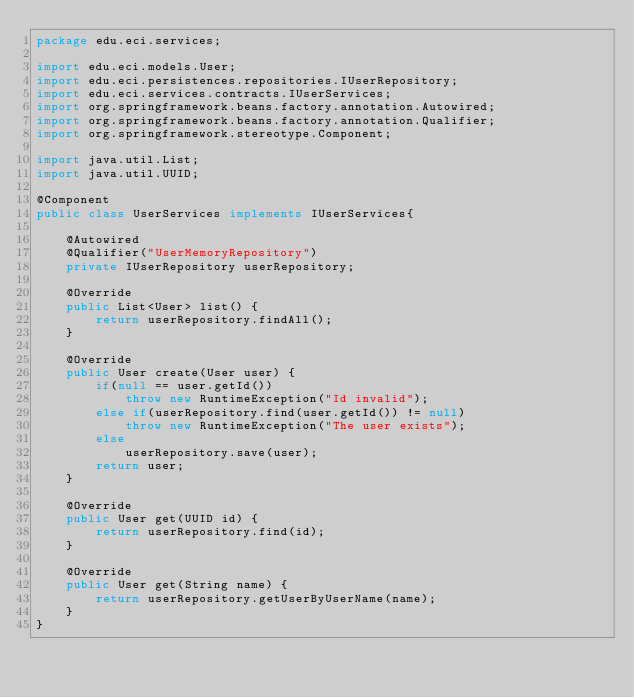<code> <loc_0><loc_0><loc_500><loc_500><_Java_>package edu.eci.services;

import edu.eci.models.User;
import edu.eci.persistences.repositories.IUserRepository;
import edu.eci.services.contracts.IUserServices;
import org.springframework.beans.factory.annotation.Autowired;
import org.springframework.beans.factory.annotation.Qualifier;
import org.springframework.stereotype.Component;

import java.util.List;
import java.util.UUID;

@Component
public class UserServices implements IUserServices{

    @Autowired
    @Qualifier("UserMemoryRepository")
    private IUserRepository userRepository;

    @Override
    public List<User> list() {
        return userRepository.findAll();
    }

    @Override
    public User create(User user) {
        if(null == user.getId())
            throw new RuntimeException("Id invalid");
        else if(userRepository.find(user.getId()) != null)
            throw new RuntimeException("The user exists");
        else
            userRepository.save(user);
        return user;
    }

    @Override
    public User get(UUID id) {
        return userRepository.find(id);
    }

    @Override
    public User get(String name) {
        return userRepository.getUserByUserName(name);
    }
}
</code> 